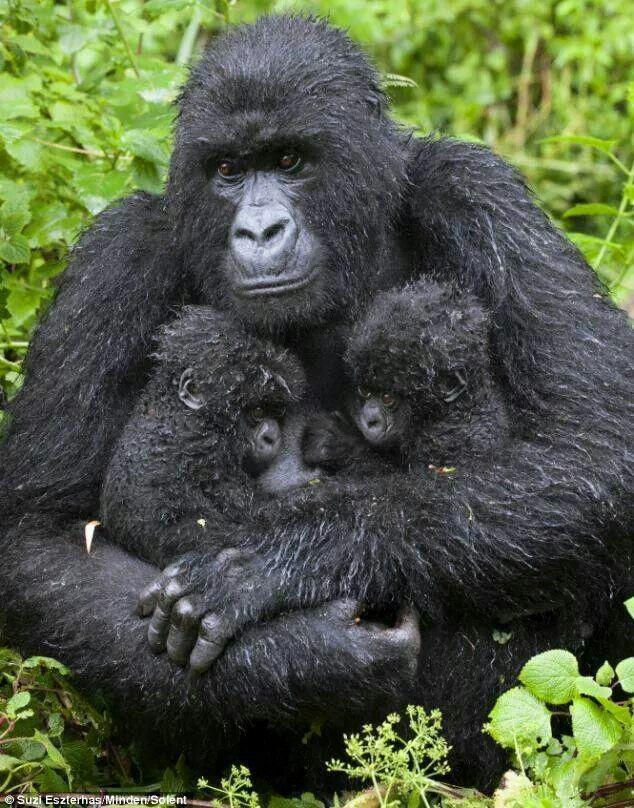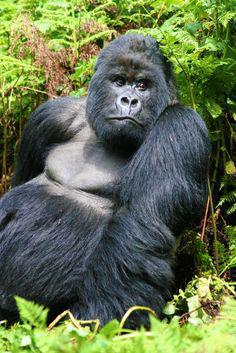The first image is the image on the left, the second image is the image on the right. For the images shown, is this caption "An adult primate holds two of its young close to its chest in the image on the left." true? Answer yes or no. Yes. The first image is the image on the left, the second image is the image on the right. For the images shown, is this caption "One image shows an adult gorilla with two infant gorillas held to its chest." true? Answer yes or no. Yes. 